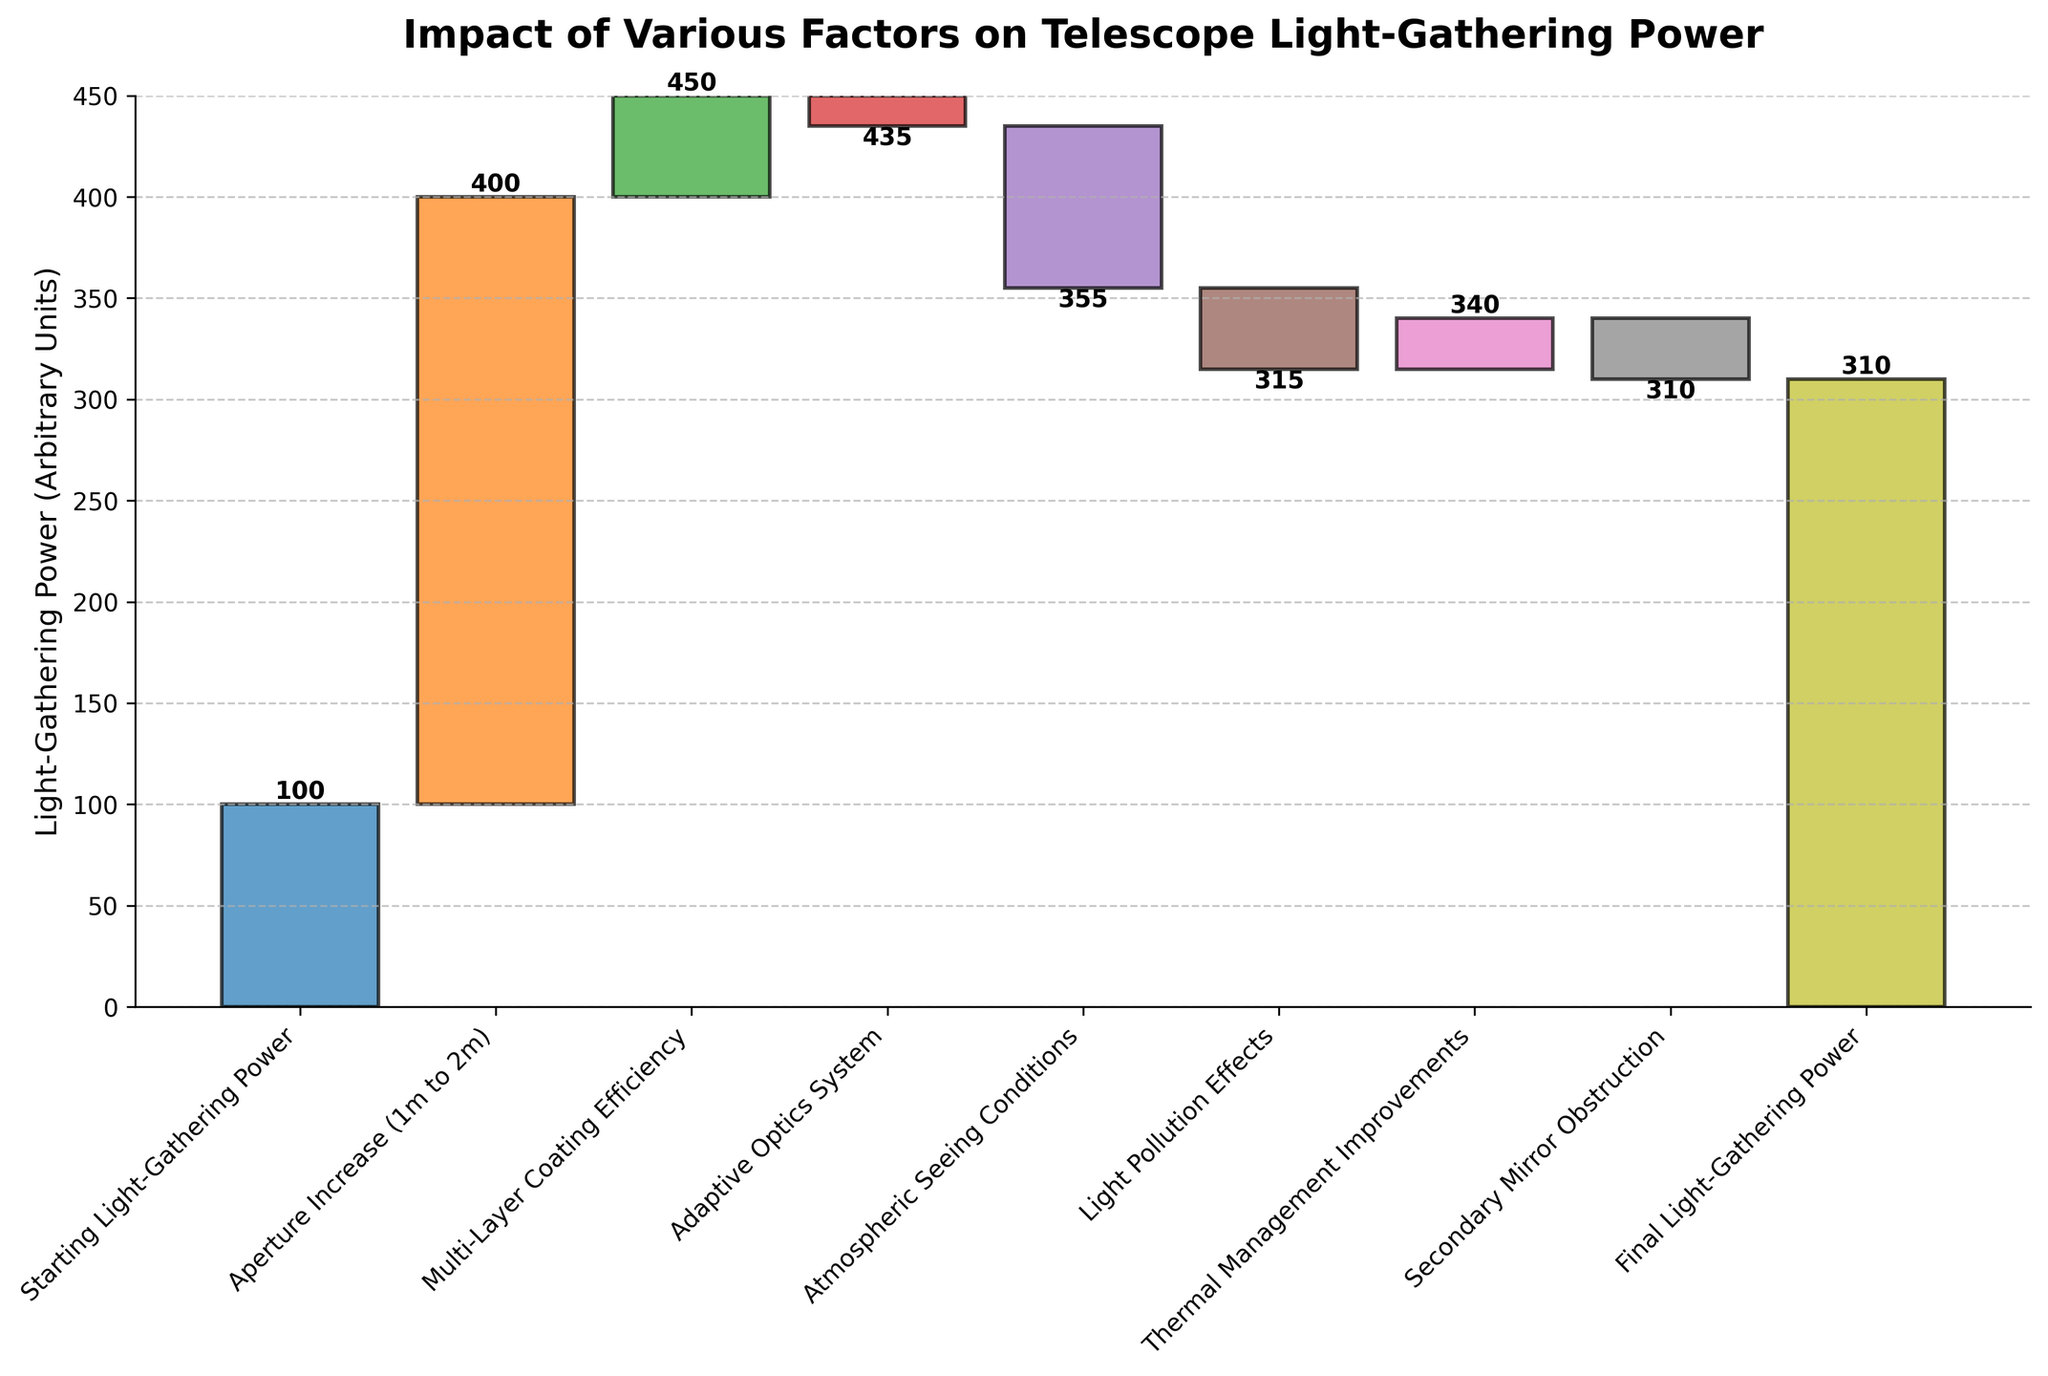What is the title of the figure? The title is displayed at the top of the figure, it reads "Impact of Various Factors on Telescope Light-Gathering Power".
Answer: Impact of Various Factors on Telescope Light-Gathering Power What is the starting value for light-gathering power in the figure? The first bar in the chart represents the Starting Light-Gathering Power, and it is labeled with the value 100.
Answer: 100 Which category has the highest positive impact on the light-gathering power? By comparing the heights of the bars, the category "Aperture Increase (1m to 2m)" has the highest positive value of 300.
Answer: Aperture Increase (1m to 2m) How does the atmospheric seeing conditions affect the light-gathering power? Looking at the bar labeled "Atmospheric Seeing Conditions," it goes downward, representing a negative impact of -80 on the light-gathering power.
Answer: -80 How many categories have a negative impact on the light-gathering power? By counting the categories with downward bars, "Adaptive Optics System," "Atmospheric Seeing Conditions," "Light Pollution Effects," and "Secondary Mirror Obstruction" have negative impacts. There are 4 such categories.
Answer: 4 What is the final light-gathering power displayed in the figure? The last cumulative value shown at the end of the waterfall chart is the "Final Light-Gathering Power" with a value of 310.
Answer: 310 Calculate the net positive impact from the given factors. The positive impacts are: 300 (Aperture Increase) + 50 (Multi-Layer Coating Efficiency) + 25 (Thermal Management Improvements) = 375. The net positive impact is 375.
Answer: 375 What is the total loss in light-gathering power due to negative factors? The negative impacts are: -15 (Adaptive Optics System) + -80 (Atmospheric Seeing Conditions) + -40 (Light Pollution Effects) + -30 (Secondary Mirror Obstruction) = -165. The total loss is 165.
Answer: 165 By how much does the Multi-Layer Coating Efficiency increase the final value compared to the Starting Light-Gathering Power? Start with the initial value of 100 and add the increase due to Multi-Layer Coating Efficiency, which is 50. The calculation is 100 + 50 = 150. Hence, the Multi-Layer Coating Efficiency increases the final value by 50 units.
Answer: 50 Which category has a greater negative impact, "Light Pollution Effects" or "Secondary Mirror Obstruction"? Comparing the negative values: "Light Pollution Effects" has a value of -40 and "Secondary Mirror Obstruction" has a value of -30. -40 is a greater negative value than -30.
Answer: Light Pollution Effects 